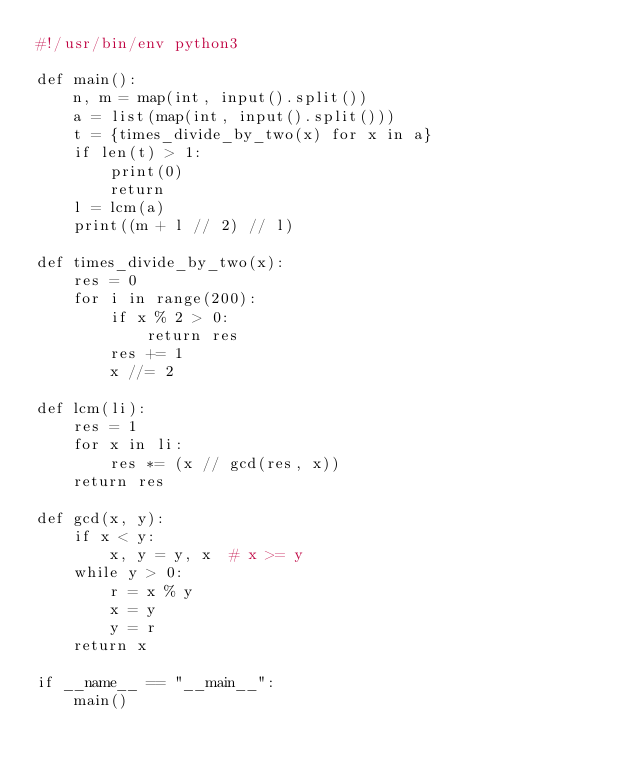Convert code to text. <code><loc_0><loc_0><loc_500><loc_500><_Python_>#!/usr/bin/env python3

def main():
    n, m = map(int, input().split())
    a = list(map(int, input().split()))
    t = {times_divide_by_two(x) for x in a}
    if len(t) > 1:
        print(0)
        return
    l = lcm(a)
    print((m + l // 2) // l)

def times_divide_by_two(x):
    res = 0
    for i in range(200):
        if x % 2 > 0:
            return res
        res += 1
        x //= 2

def lcm(li):
    res = 1
    for x in li:
        res *= (x // gcd(res, x))
    return res

def gcd(x, y):
    if x < y:
        x, y = y, x  # x >= y
    while y > 0:
        r = x % y
        x = y
        y = r
    return x

if __name__ == "__main__":
    main()
</code> 